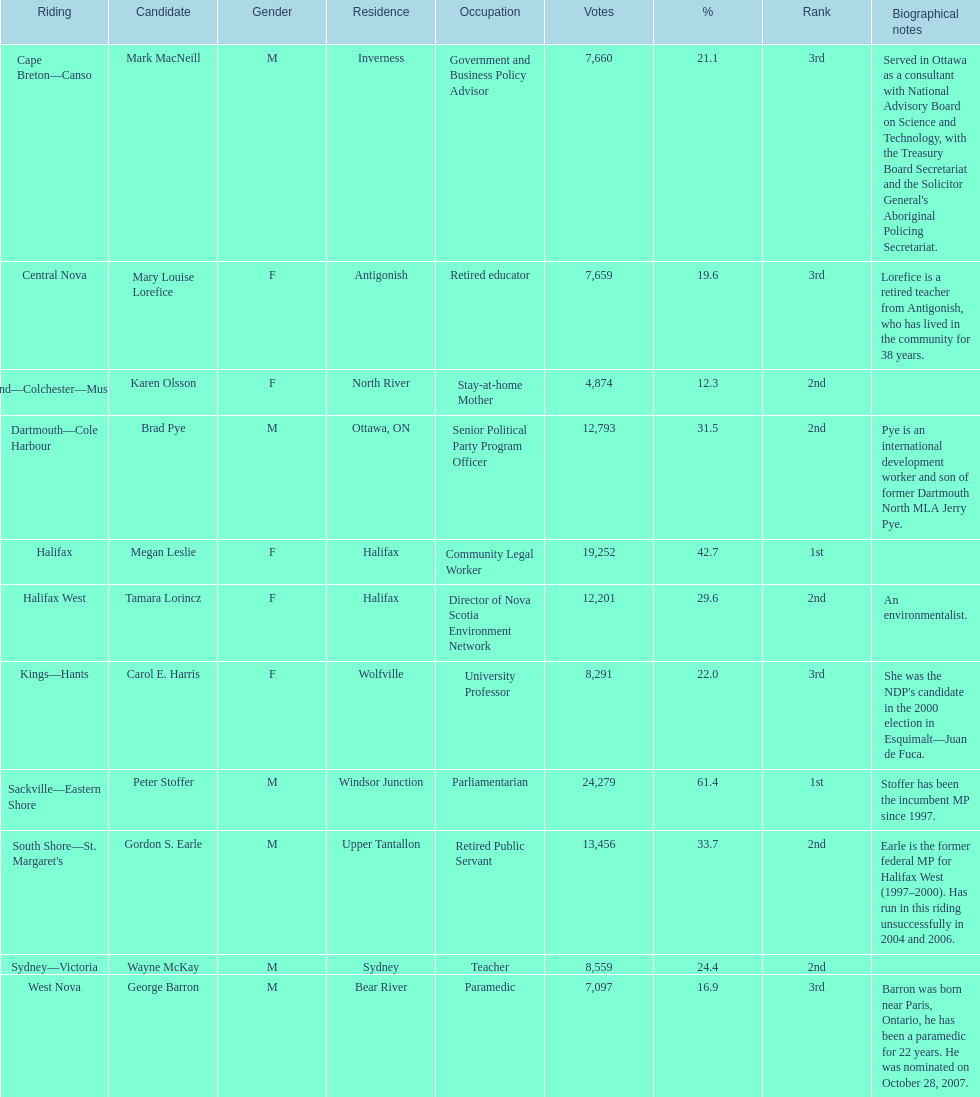How many of the contenders were females? 5. 